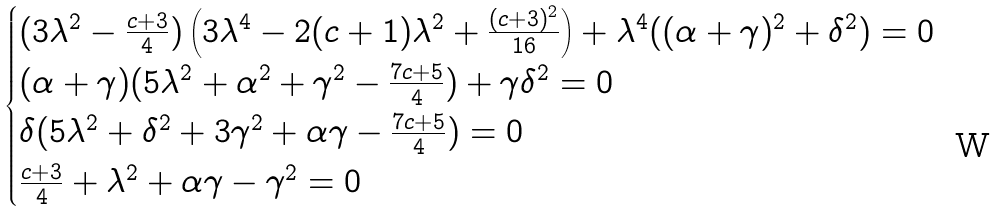<formula> <loc_0><loc_0><loc_500><loc_500>\begin{cases} ( 3 \lambda ^ { 2 } - \frac { c + 3 } { 4 } ) \left ( 3 \lambda ^ { 4 } - 2 ( c + 1 ) \lambda ^ { 2 } + \frac { ( c + 3 ) ^ { 2 } } { 1 6 } \right ) + \lambda ^ { 4 } ( ( \alpha + \gamma ) ^ { 2 } + \delta ^ { 2 } ) = 0 \\ ( \alpha + \gamma ) ( 5 \lambda ^ { 2 } + \alpha ^ { 2 } + \gamma ^ { 2 } - \frac { 7 c + 5 } { 4 } ) + \gamma \delta ^ { 2 } = 0 \\ \delta ( 5 \lambda ^ { 2 } + \delta ^ { 2 } + 3 \gamma ^ { 2 } + \alpha \gamma - \frac { 7 c + 5 } { 4 } ) = 0 \\ \frac { c + 3 } { 4 } + \lambda ^ { 2 } + \alpha \gamma - \gamma ^ { 2 } = 0 \end{cases}</formula> 